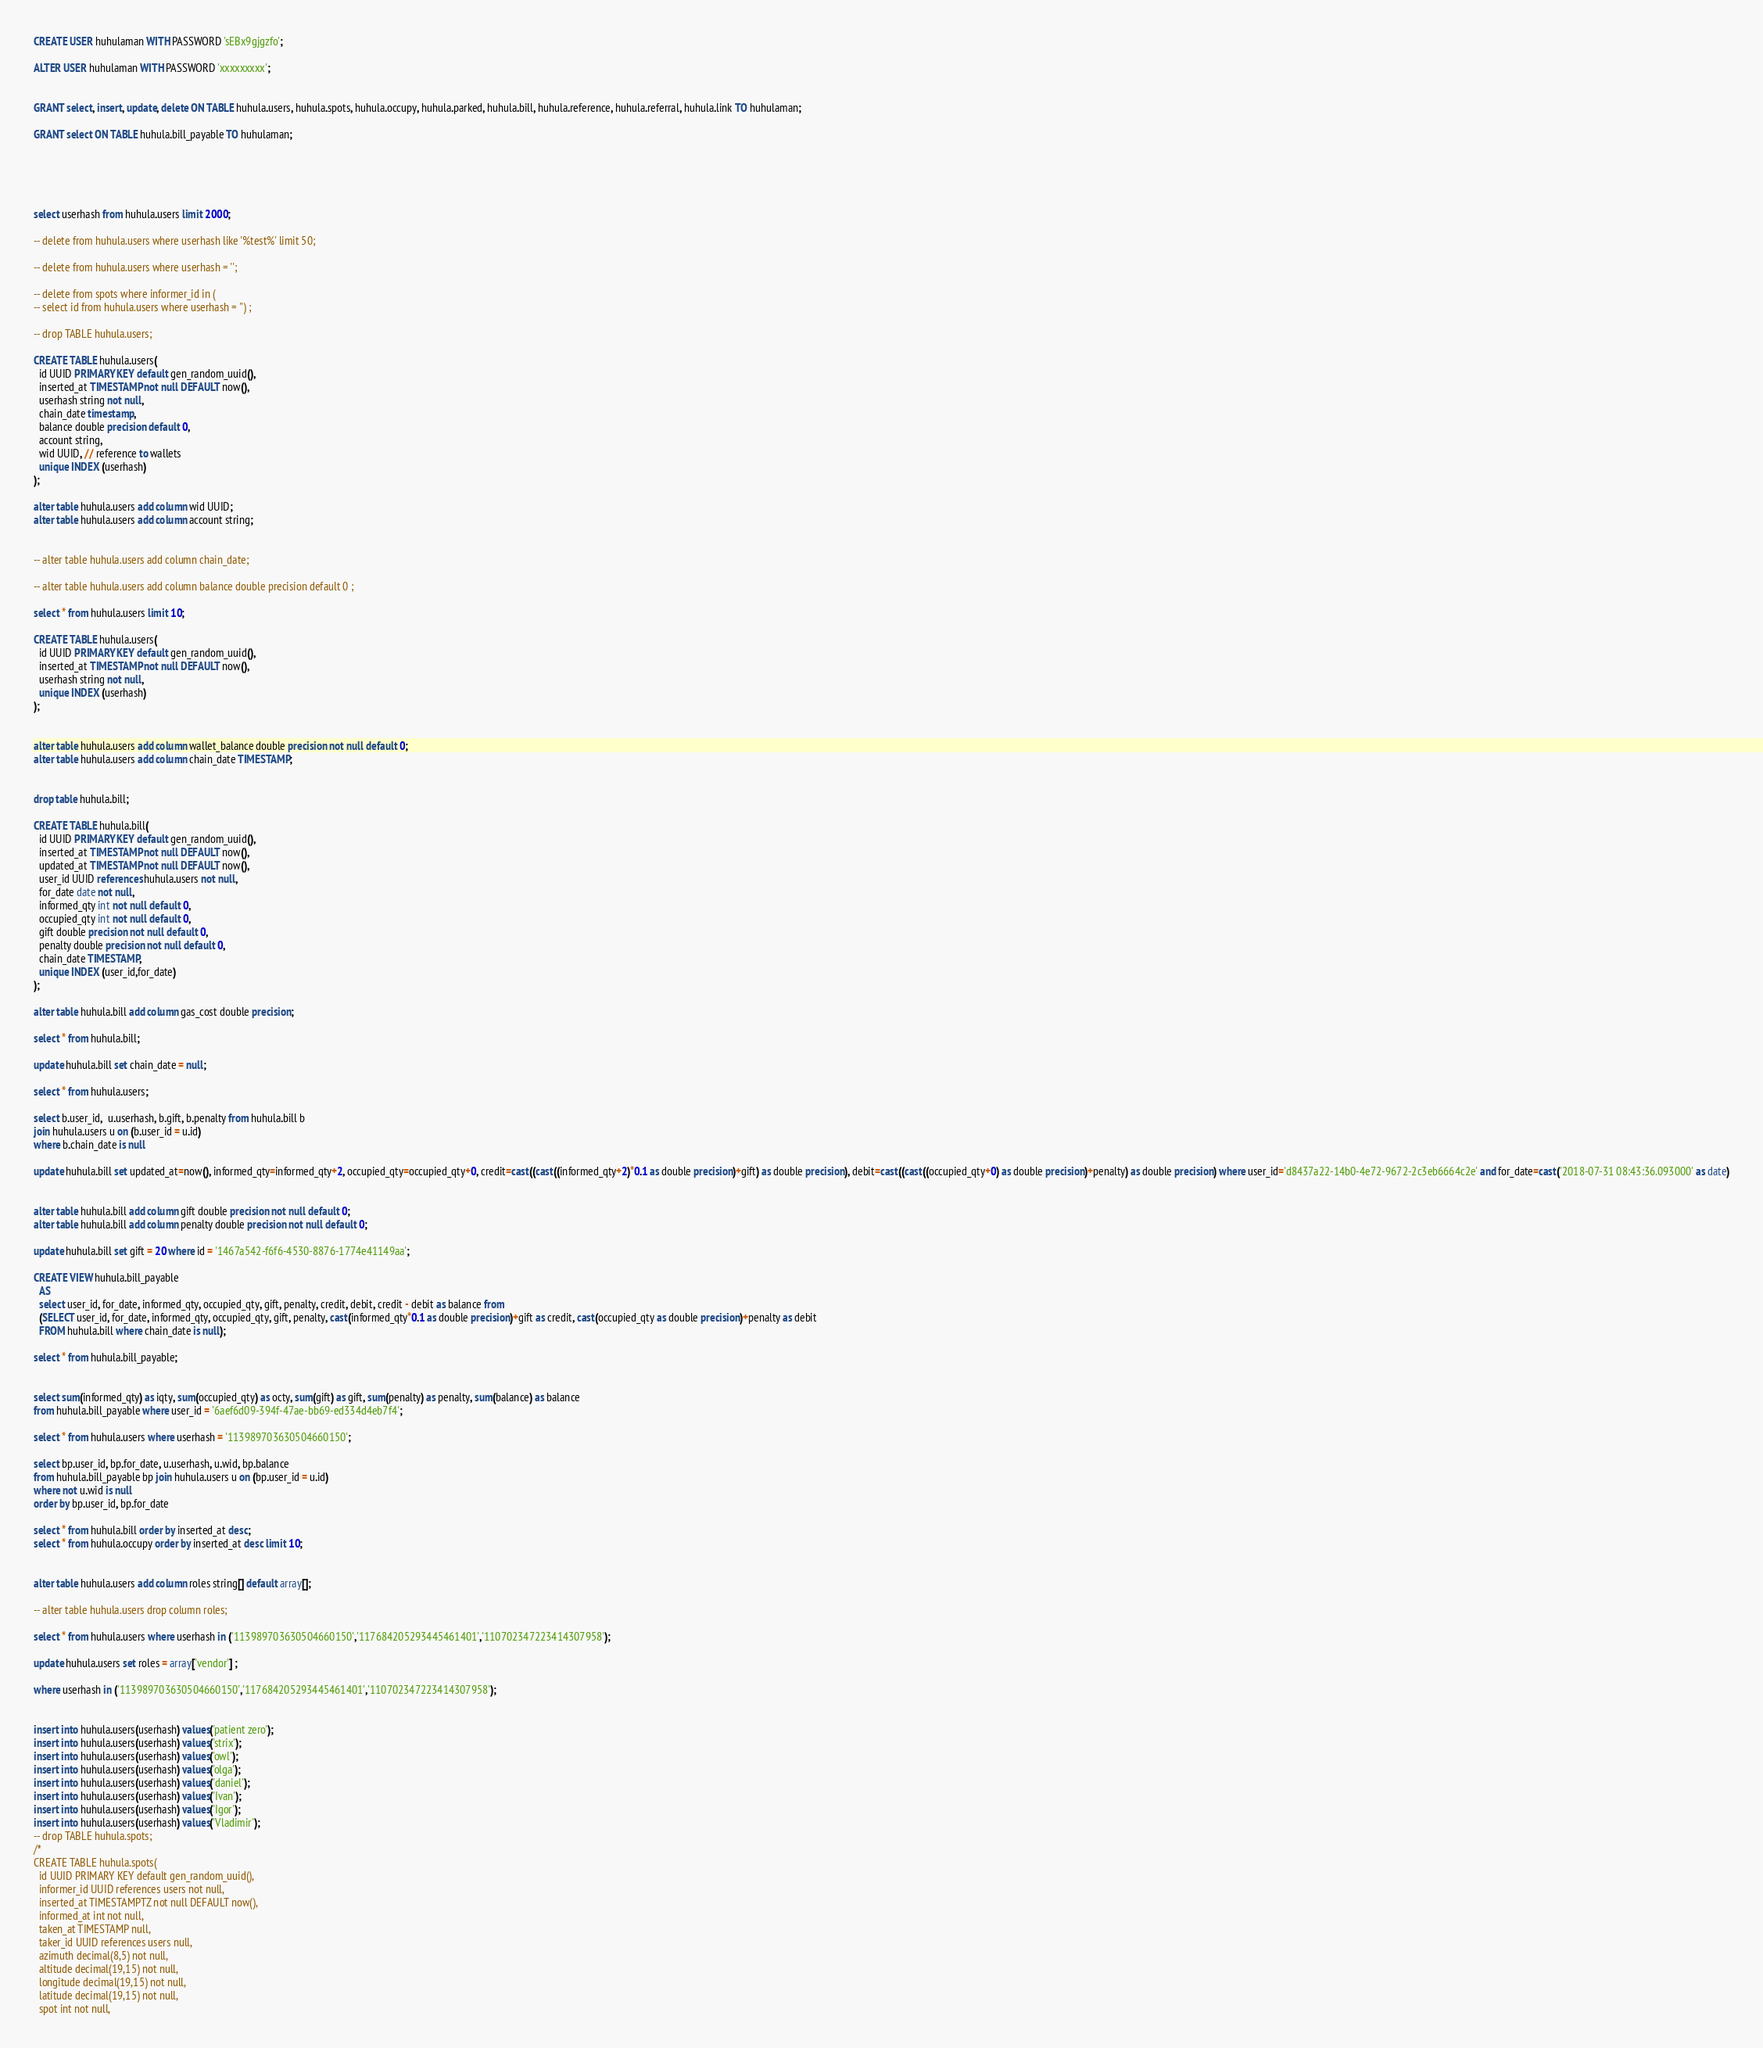Convert code to text. <code><loc_0><loc_0><loc_500><loc_500><_SQL_>
CREATE USER huhulaman WITH PASSWORD 'sEBx9gjgzfo';

ALTER USER huhulaman WITH PASSWORD 'xxxxxxxxx';


GRANT select, insert, update, delete ON TABLE huhula.users, huhula.spots, huhula.occupy, huhula.parked, huhula.bill, huhula.reference, huhula.referral, huhula.link TO huhulaman;

GRANT select ON TABLE huhula.bill_payable TO huhulaman;



 

select userhash from huhula.users limit 2000;

-- delete from huhula.users where userhash like '%test%' limit 50;

-- delete from huhula.users where userhash = '';

-- delete from spots where informer_id in (
-- select id from huhula.users where userhash = '') ;

-- drop TABLE huhula.users;

CREATE TABLE huhula.users(
  id UUID PRIMARY KEY default gen_random_uuid(),
  inserted_at TIMESTAMP not null DEFAULT now(),
  userhash string not null,
  chain_date timestamp,
  balance double precision default 0,
  account string, 
  wid UUID, // reference to wallets 
  unique INDEX (userhash)
);  

alter table huhula.users add column wid UUID;
alter table huhula.users add column account string;


-- alter table huhula.users add column chain_date;

-- alter table huhula.users add column balance double precision default 0 ;

select * from huhula.users limit 10;

CREATE TABLE huhula.users(
  id UUID PRIMARY KEY default gen_random_uuid(),
  inserted_at TIMESTAMP not null DEFAULT now(),
  userhash string not null,
  unique INDEX (userhash)
);  


alter table huhula.users add column wallet_balance double precision not null default 0;
alter table huhula.users add column chain_date TIMESTAMP;


drop table huhula.bill;

CREATE TABLE huhula.bill(
  id UUID PRIMARY KEY default gen_random_uuid(),
  inserted_at TIMESTAMP not null DEFAULT now(),
  updated_at TIMESTAMP not null DEFAULT now(),
  user_id UUID references huhula.users not null,
  for_date date not null,
  informed_qty int not null default 0,
  occupied_qty int not null default 0,
  gift double precision not null default 0,
  penalty double precision not null default 0,
  chain_date TIMESTAMP,
  unique INDEX (user_id,for_date)
);  

alter table huhula.bill add column gas_cost double precision;

select * from huhula.bill;

update huhula.bill set chain_date = null;

select * from huhula.users;

select b.user_id,  u.userhash, b.gift, b.penalty from huhula.bill b 
join huhula.users u on (b.user_id = u.id) 
where b.chain_date is null 

update huhula.bill set updated_at=now(), informed_qty=informed_qty+2, occupied_qty=occupied_qty+0, credit=cast((cast((informed_qty+2)*0.1 as double precision)+gift) as double precision), debit=cast((cast((occupied_qty+0) as double precision)+penalty) as double precision) where user_id='d8437a22-14b0-4e72-9672-2c3eb6664c2e' and for_date=cast('2018-07-31 08:43:36.093000' as date)


alter table huhula.bill add column gift double precision not null default 0;
alter table huhula.bill add column penalty double precision not null default 0;

update huhula.bill set gift = 20 where id = '1467a542-f6f6-4530-8876-1774e41149aa';

CREATE VIEW huhula.bill_payable
  AS 
  select user_id, for_date, informed_qty, occupied_qty, gift, penalty, credit, debit, credit - debit as balance from
  (SELECT user_id, for_date, informed_qty, occupied_qty, gift, penalty, cast(informed_qty*0.1 as double precision)+gift as credit, cast(occupied_qty as double precision)+penalty as debit 
  FROM huhula.bill where chain_date is null);

select * from huhula.bill_payable;


select sum(informed_qty) as iqty, sum(occupied_qty) as octy, sum(gift) as gift, sum(penalty) as penalty, sum(balance) as balance 
from huhula.bill_payable where user_id = '6aef6d09-394f-47ae-bb69-ed334d4eb7f4';

select * from huhula.users where userhash = '113989703630504660150';
  
select bp.user_id, bp.for_date, u.userhash, u.wid, bp.balance 
from huhula.bill_payable bp join huhula.users u on (bp.user_id = u.id) 
where not u.wid is null
order by bp.user_id, bp.for_date

select * from huhula.bill order by inserted_at desc;
select * from huhula.occupy order by inserted_at desc limit 10;


alter table huhula.users add column roles string[] default array[];  

-- alter table huhula.users drop column roles;  

select * from huhula.users where userhash in ('113989703630504660150','117684205293445461401','110702347223414307958');

update huhula.users set roles = array['vendor'] ;

where userhash in ('113989703630504660150','117684205293445461401','110702347223414307958');


insert into huhula.users(userhash) values('patient zero');
insert into huhula.users(userhash) values('strix');
insert into huhula.users(userhash) values('owl');
insert into huhula.users(userhash) values('olga');
insert into huhula.users(userhash) values('daniel');
insert into huhula.users(userhash) values('Ivan');
insert into huhula.users(userhash) values('Igor');
insert into huhula.users(userhash) values('Vladimir');
-- drop TABLE huhula.spots;
/*
CREATE TABLE huhula.spots(
  id UUID PRIMARY KEY default gen_random_uuid(),
  informer_id UUID references users not null,
  inserted_at TIMESTAMPTZ not null DEFAULT now(),
  informed_at int not null,
  taken_at TIMESTAMP null,
  taker_id UUID references users null,
  azimuth decimal(8,5) not null,
  altitude decimal(19,15) not null,
  longitude decimal(19,15) not null,
  latitude decimal(19,15) not null,
  spot int not null,</code> 